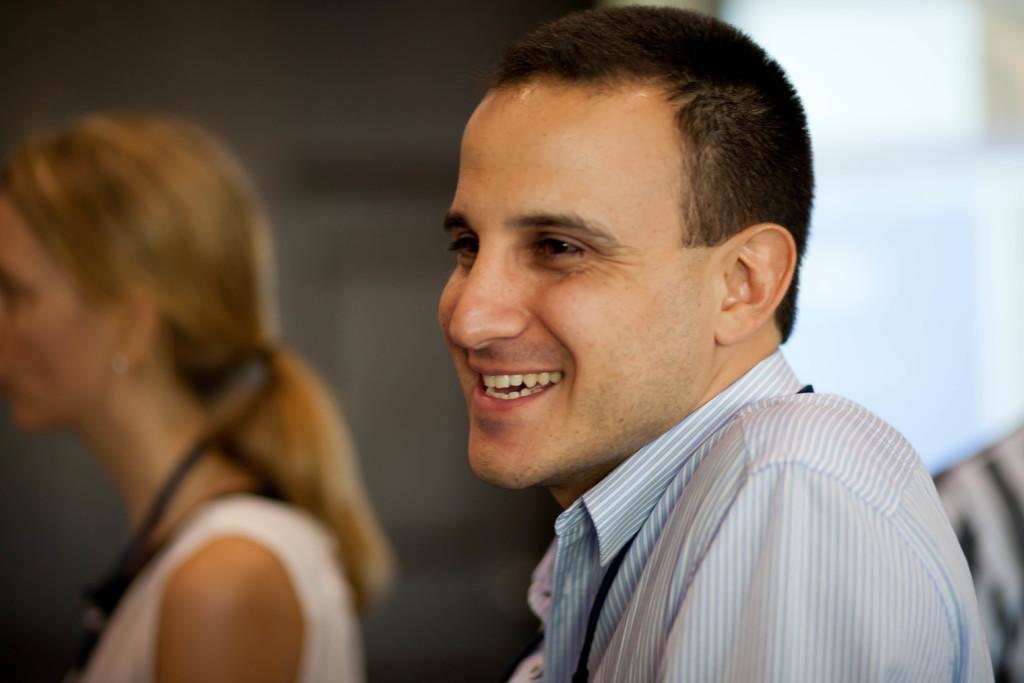What is the expression of the person in the image? The person in the image is smiling. Can you describe the other people present in the image? Unfortunately, the provided facts do not give any details about the other people in the image. What type of brass instrument is the scarecrow playing in the image? There is no scarecrow or brass instrument present in the image. 